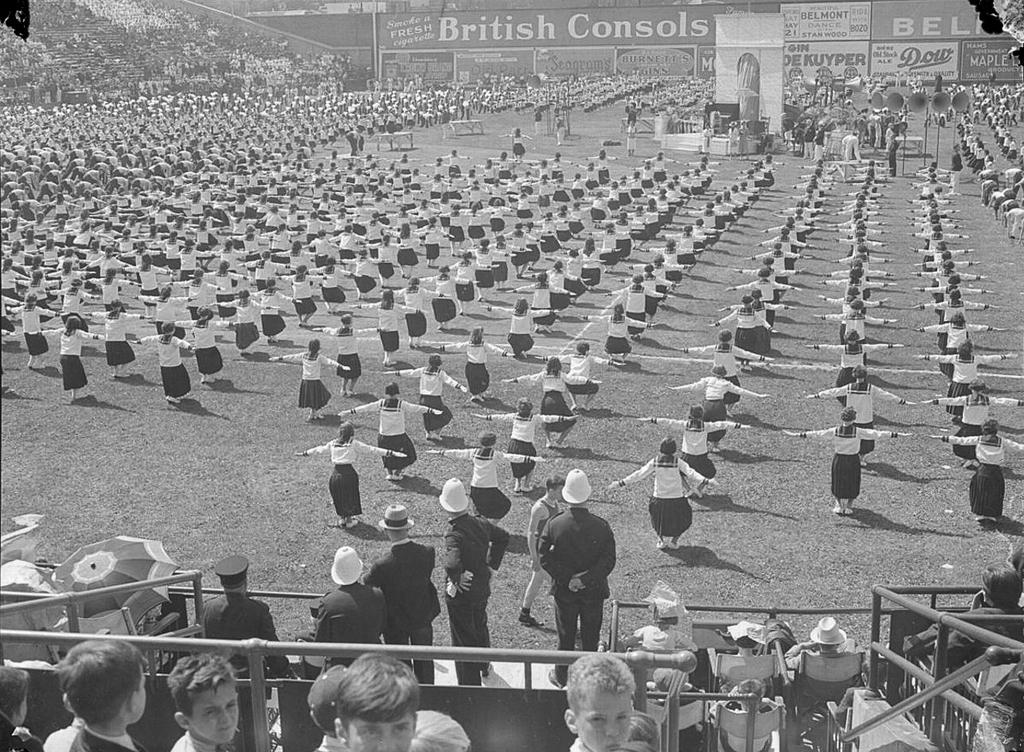What is the color scheme of the image? The image is black and white. What can be seen in the image? There is a crowd in the image. What objects are present in the image besides the crowd? There are boards in the image. How many clovers can be seen in the image? There are no clovers present in the image. What type of parent is depicted in the image? There is no parent depicted in the image. 